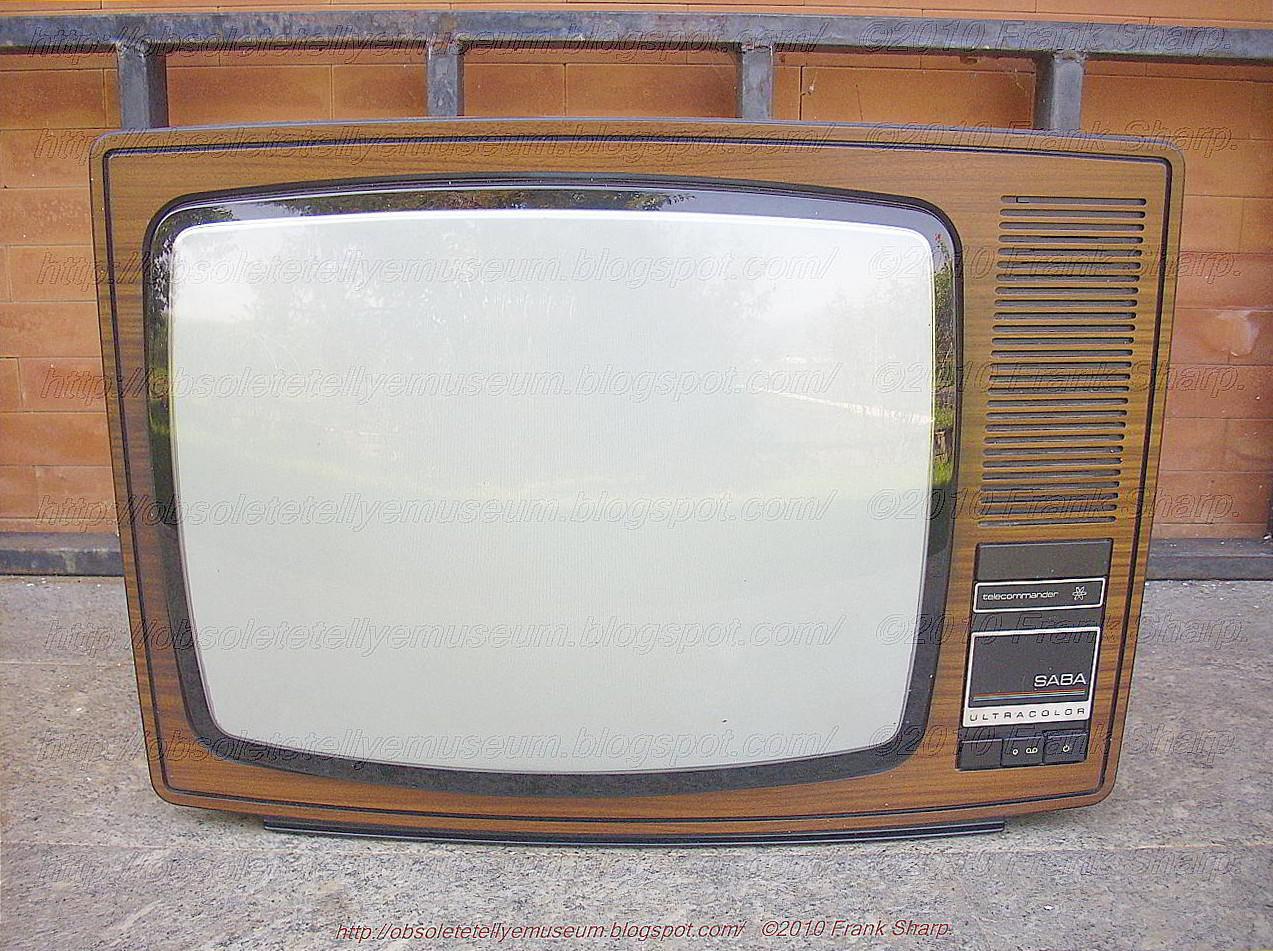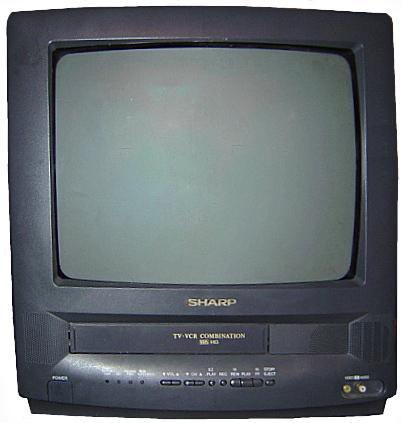The first image is the image on the left, the second image is the image on the right. Analyze the images presented: Is the assertion "the left pic is of a flat screen monitor" valid? Answer yes or no. No. The first image is the image on the left, the second image is the image on the right. For the images shown, is this caption "The left image has a remote next to a monitor on a wooden surface" true? Answer yes or no. No. 